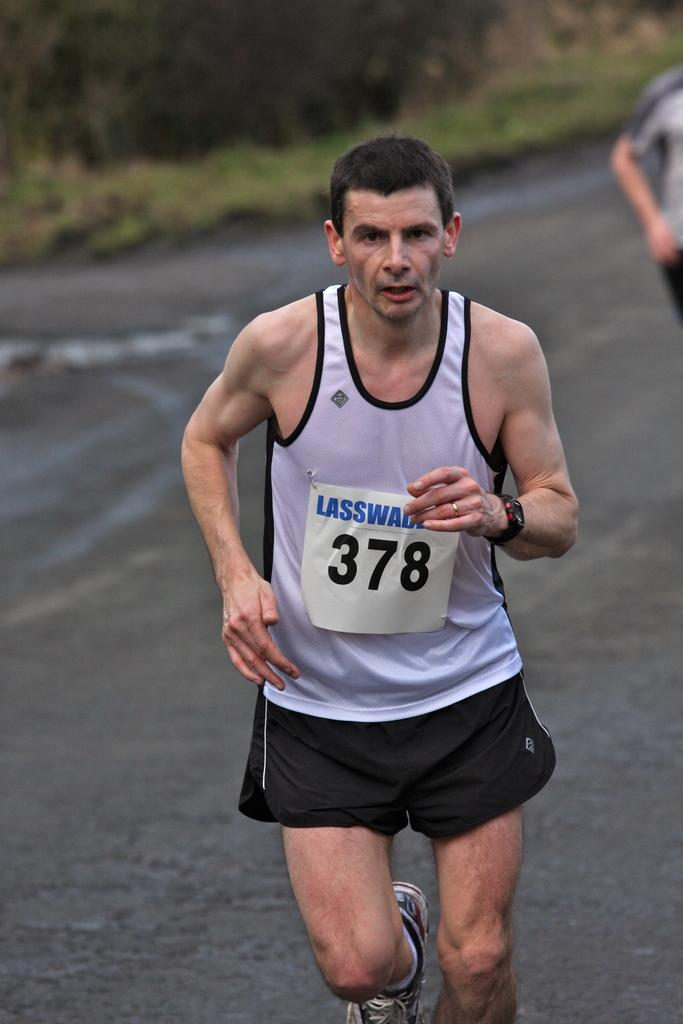<image>
Write a terse but informative summary of the picture. A man wearing the number 378 runs in a road. 